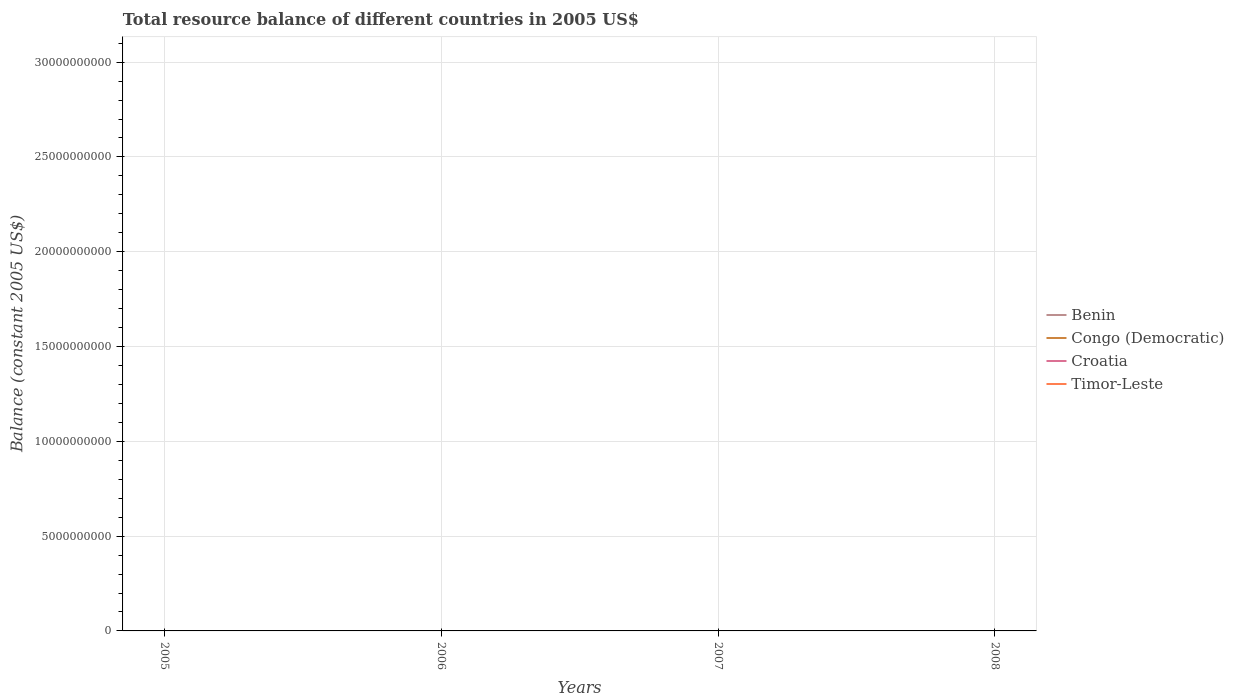Does the line corresponding to Croatia intersect with the line corresponding to Benin?
Your response must be concise. No. Is the number of lines equal to the number of legend labels?
Your answer should be very brief. No. What is the difference between the highest and the lowest total resource balance in Timor-Leste?
Your answer should be compact. 0. Is the total resource balance in Timor-Leste strictly greater than the total resource balance in Croatia over the years?
Provide a succinct answer. No. Are the values on the major ticks of Y-axis written in scientific E-notation?
Provide a short and direct response. No. Does the graph contain any zero values?
Ensure brevity in your answer.  Yes. How are the legend labels stacked?
Offer a terse response. Vertical. What is the title of the graph?
Make the answer very short. Total resource balance of different countries in 2005 US$. What is the label or title of the Y-axis?
Your answer should be compact. Balance (constant 2005 US$). What is the Balance (constant 2005 US$) of Croatia in 2006?
Make the answer very short. 0. What is the Balance (constant 2005 US$) in Croatia in 2007?
Make the answer very short. 0. What is the Balance (constant 2005 US$) of Croatia in 2008?
Your answer should be very brief. 0. What is the total Balance (constant 2005 US$) of Timor-Leste in the graph?
Your answer should be compact. 0. What is the average Balance (constant 2005 US$) in Croatia per year?
Ensure brevity in your answer.  0. 